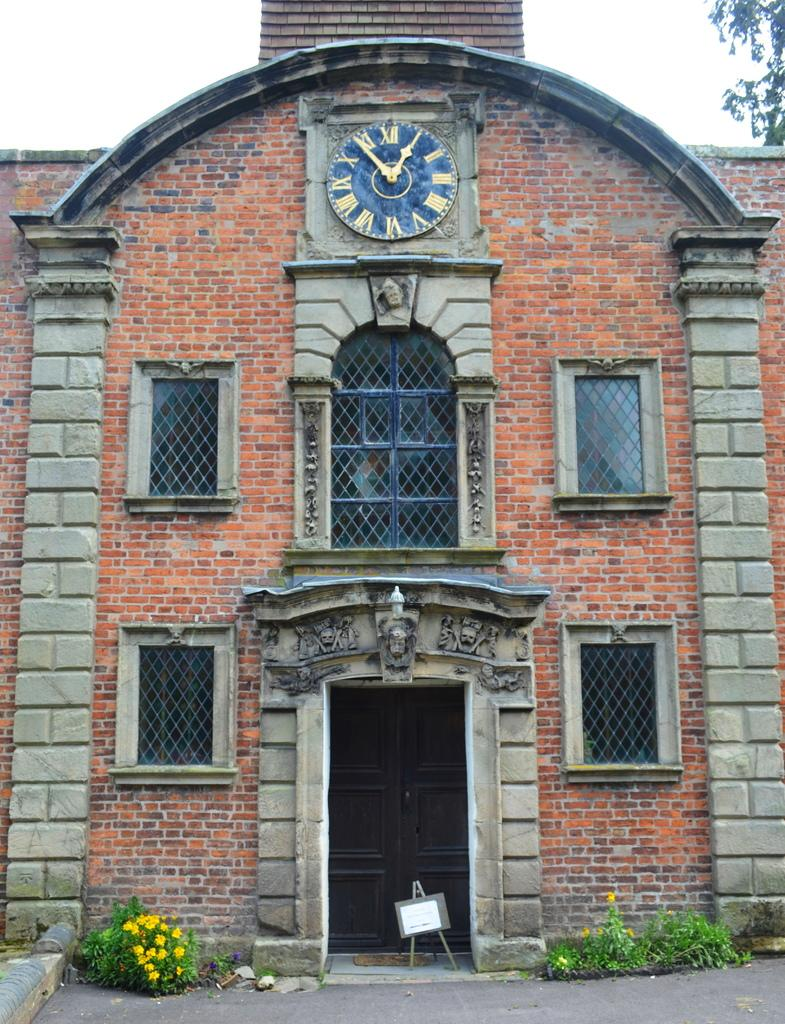What type of structure is present in the image? There is a building in the image. What feature can be seen on the building? The building has a clock on it. What type of vegetation is present on either side of the image? There are flowering plants on either side of the image. What is visible at the top of the image? The sky is visible at the top of the image. How many houses are visible in the image? There are no houses visible in the image; it only features a building with a clock and flowering plants on either side. Can you describe the person walking in front of the building in the image? There is no person present in the image. 